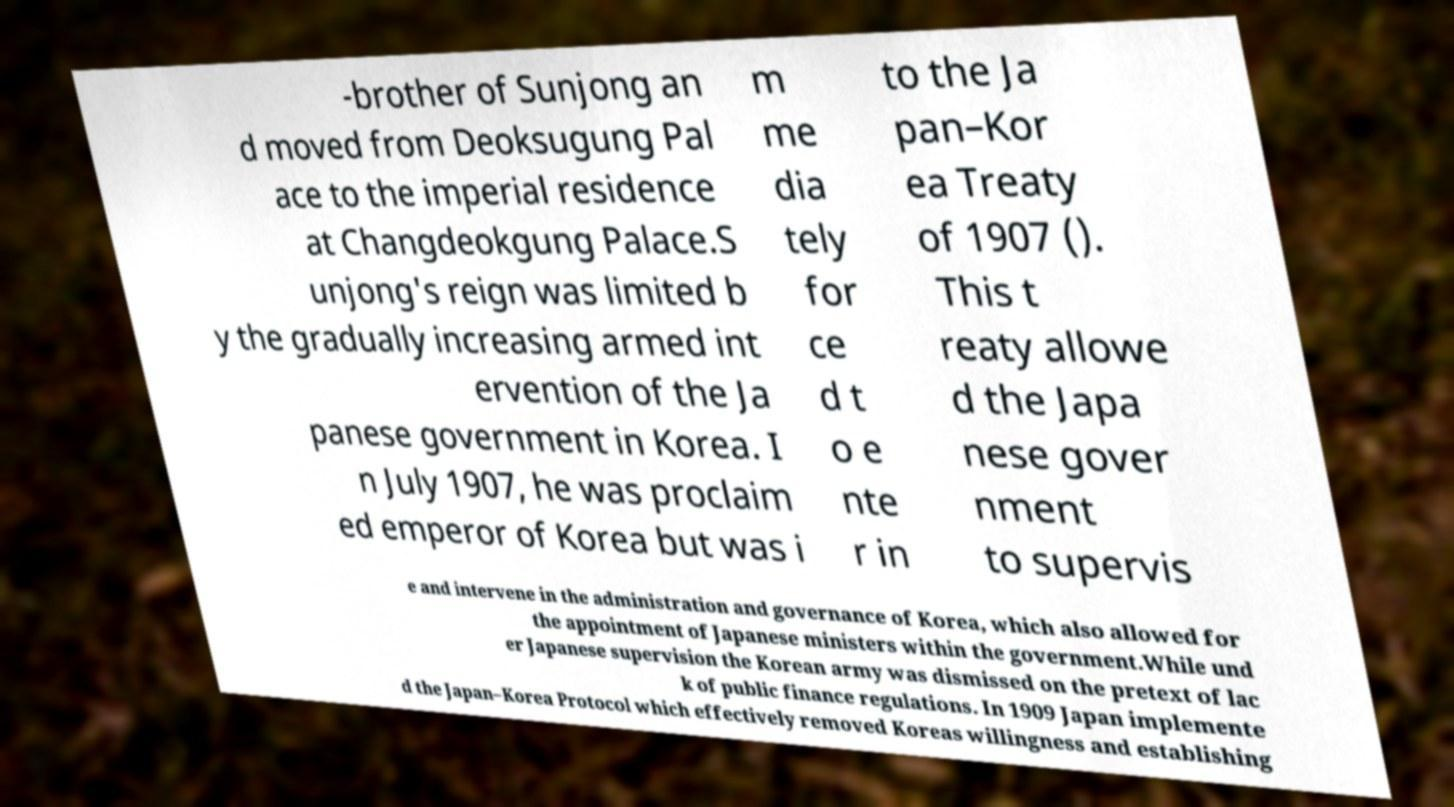Can you read and provide the text displayed in the image?This photo seems to have some interesting text. Can you extract and type it out for me? -brother of Sunjong an d moved from Deoksugung Pal ace to the imperial residence at Changdeokgung Palace.S unjong's reign was limited b y the gradually increasing armed int ervention of the Ja panese government in Korea. I n July 1907, he was proclaim ed emperor of Korea but was i m me dia tely for ce d t o e nte r in to the Ja pan–Kor ea Treaty of 1907 (). This t reaty allowe d the Japa nese gover nment to supervis e and intervene in the administration and governance of Korea, which also allowed for the appointment of Japanese ministers within the government.While und er Japanese supervision the Korean army was dismissed on the pretext of lac k of public finance regulations. In 1909 Japan implemente d the Japan–Korea Protocol which effectively removed Koreas willingness and establishing 